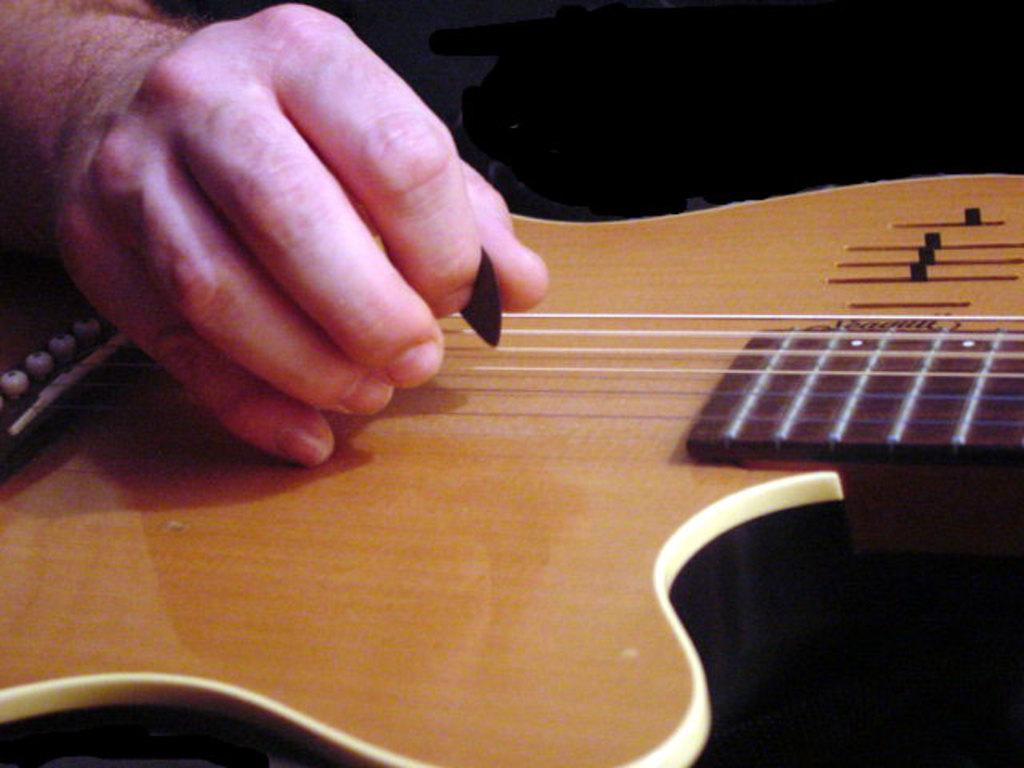What is the main subject of the image? There is a person in the image. What is the person doing in the image? The person is playing a guitar. What type of sheet is the person using to play the guitar in the image? There is no sheet present in the image; the person is playing the guitar without any additional materials. 